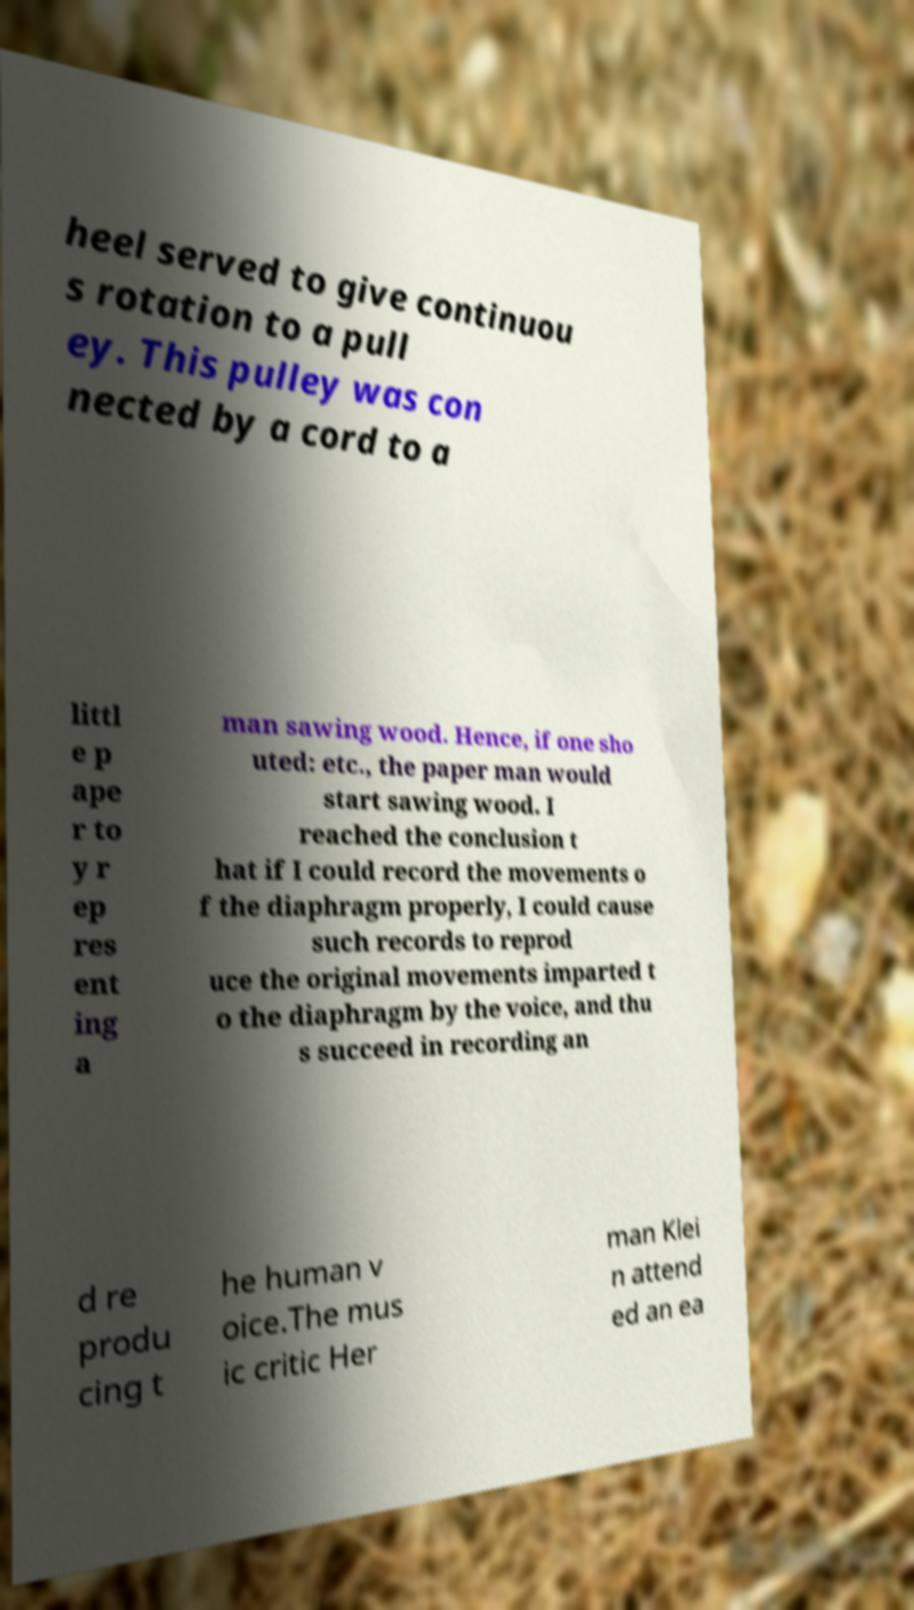Can you accurately transcribe the text from the provided image for me? heel served to give continuou s rotation to a pull ey. This pulley was con nected by a cord to a littl e p ape r to y r ep res ent ing a man sawing wood. Hence, if one sho uted: etc., the paper man would start sawing wood. I reached the conclusion t hat if I could record the movements o f the diaphragm properly, I could cause such records to reprod uce the original movements imparted t o the diaphragm by the voice, and thu s succeed in recording an d re produ cing t he human v oice.The mus ic critic Her man Klei n attend ed an ea 